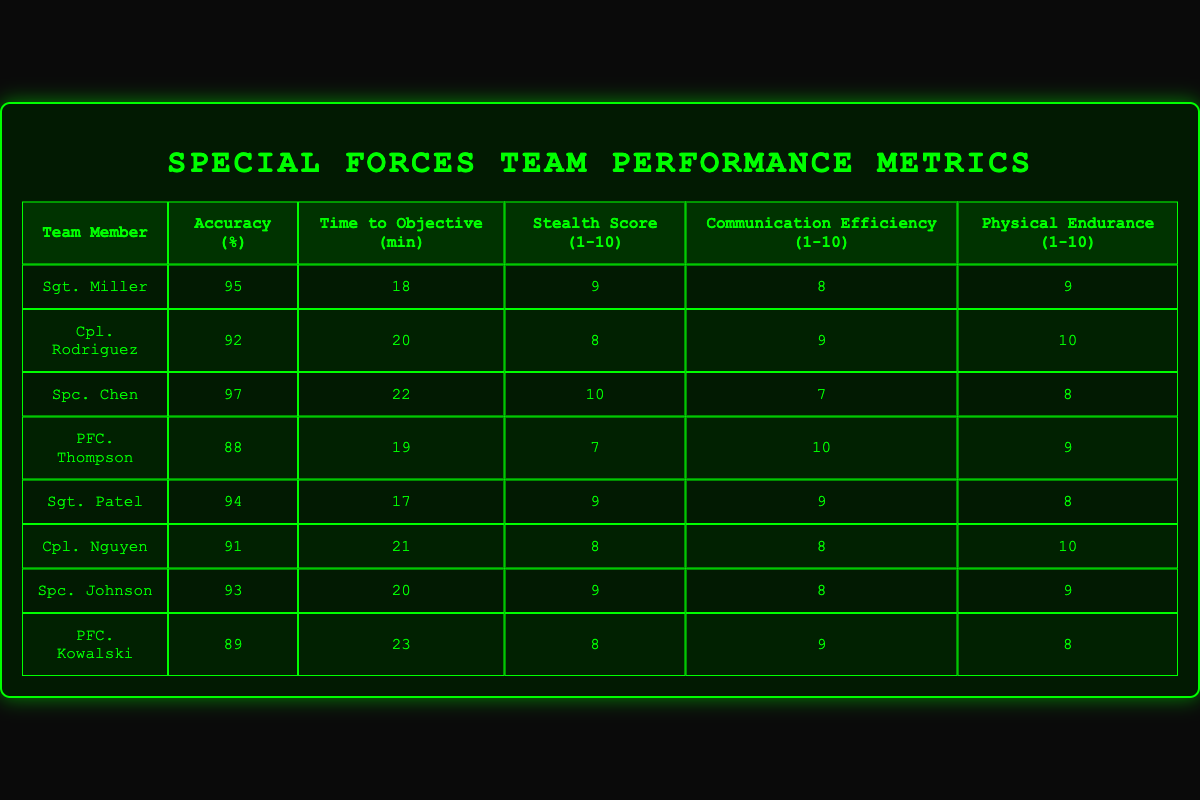What is the highest accuracy percentage achieved by a team member? By reviewing the "Accuracy (%)" column, we can identify that Sgt. Chen has the highest accuracy percentage of 97.
Answer: 97 Which team member took the longest time to reach the objective? Looking at the "Time to Objective (min)" column, PFC. Kowalski took the longest time with 23 minutes.
Answer: 23 Is Sgt. Patel's Stealth Score higher than PFC. Thompson's? Sgt. Patel has a Stealth Score of 9, while PFC. Thompson has a Stealth Score of 7. Thus, Sgt. Patel's score is higher.
Answer: Yes What is the average Communication Efficiency of the team members? Adding the Communication Efficiency scores (8 + 9 + 7 + 10 + 9 + 8 + 8 + 9 = 68) and dividing by 8 team members gives an average of 68/8 = 8.5.
Answer: 8.5 Between Cpl. Rodriguez and Cpl. Nguyen, who has a better Physical Endurance score? Cpl. Rodriguez's Physical Endurance score is 10, while Cpl. Nguyen's is 10. They have the same score, indicating neither has a better score.
Answer: Neither What is the total time taken by all team members to complete their objectives? Summing the "Time to Objective (min)" column gives us (18 + 20 + 22 + 19 + 17 + 21 + 20 + 23 = 180) minutes in total.
Answer: 180 Which team member has the lowest overall score based on Stealth, Communication, and Physical Endurance metrics? Aggregating the Stealth, Communication, and Physical Endurance scores: PFC. Kowalski (8 + 9 + 8 = 25), PFC. Thompson (7 + 10 + 9 = 26), etc. results in PFC. Thompson having the lowest sum of 26.
Answer: PFC. Thompson How many team members have an Accuracy Percentage greater than 90? By reviewing the "Accuracy (%)" column, the following members are greater than 90: Sgt. Miller, Cpl. Rodriguez, Spc. Chen, Sgt. Patel, Cpl. Nguyen, and Spc. Johnson, totalling to 6 members.
Answer: 6 Which team member has the highest combination of Stealth, Communication Efficiency, and Physical Endurance scores? Adding up the scores for each team member: Sgt. Patel (9 + 9 + 8 = 26), Cpl. Rodriguez (8 + 9 + 10 = 27), Spc. Chen (10 + 7 + 8 = 25), etc. reveals Cpl. Rodriguez has the highest combined score of 27.
Answer: Cpl. Rodriguez 